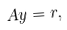Convert formula to latex. <formula><loc_0><loc_0><loc_500><loc_500>A y = r ,</formula> 